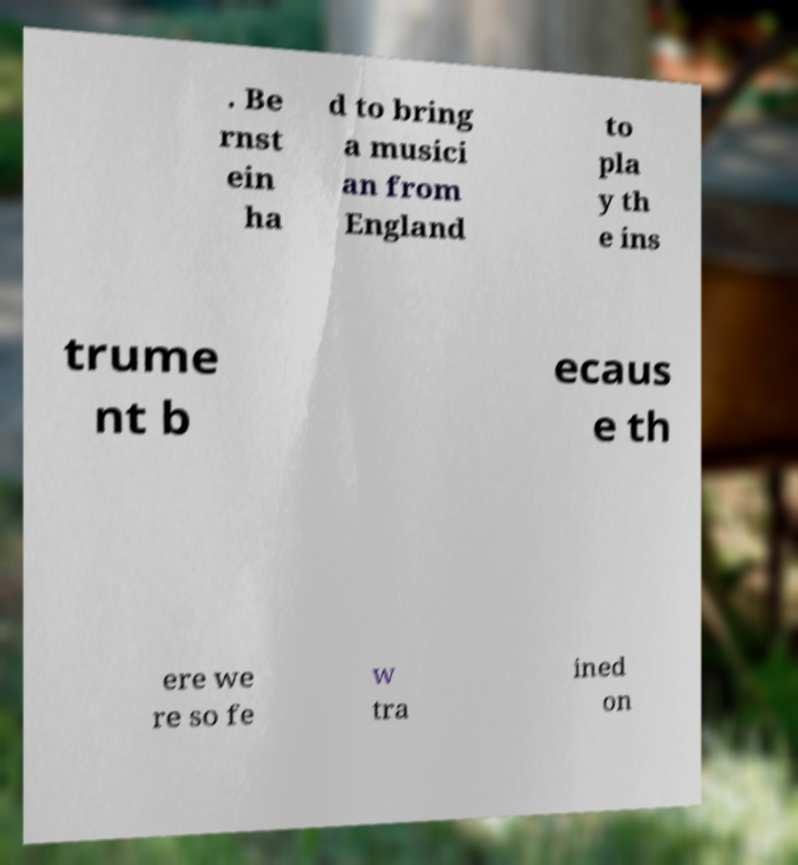Can you accurately transcribe the text from the provided image for me? . Be rnst ein ha d to bring a musici an from England to pla y th e ins trume nt b ecaus e th ere we re so fe w tra ined on 